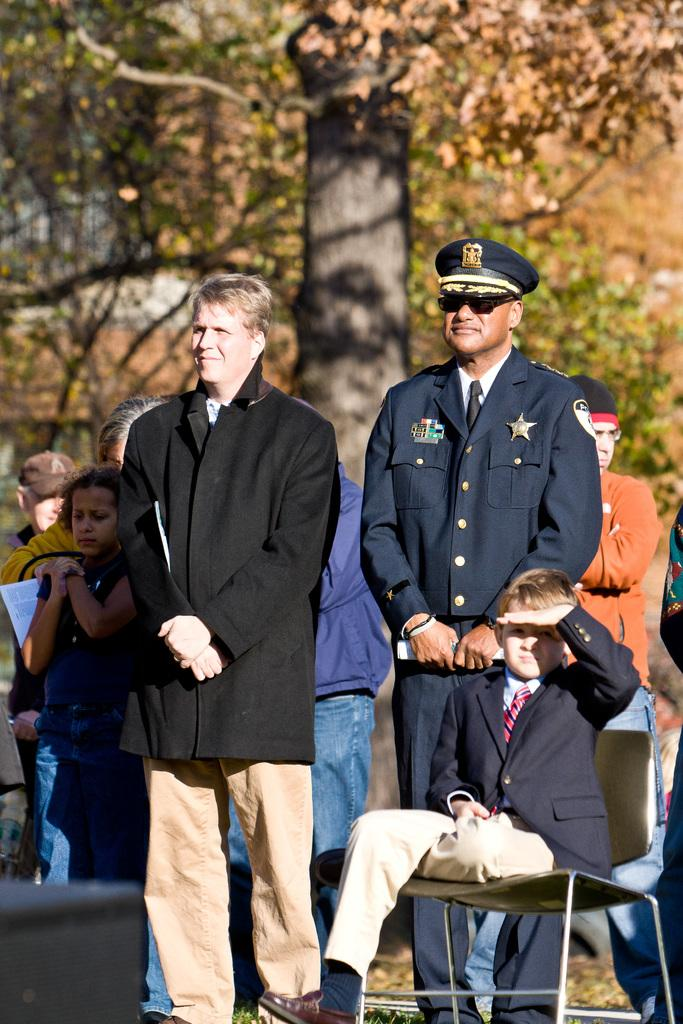What is the primary activity of the people in the image? The people in the image are standing, which suggests they might be waiting or observing something. What is the boy's position in the image? The boy is sitting on a chair in the image. What can be seen in the distance behind the people? There are trees visible in the background of the image. What type of apparel is the beam wearing in the image? There is no beam present in the image, and therefore no apparel can be attributed to it. 